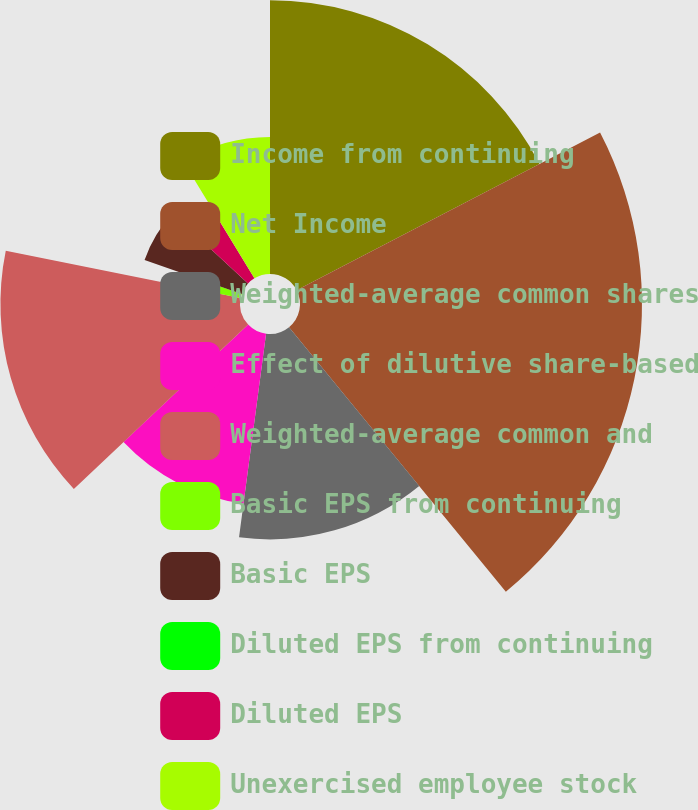Convert chart. <chart><loc_0><loc_0><loc_500><loc_500><pie_chart><fcel>Income from continuing<fcel>Net Income<fcel>Weighted-average common shares<fcel>Effect of dilutive share-based<fcel>Weighted-average common and<fcel>Basic EPS from continuing<fcel>Basic EPS<fcel>Diluted EPS from continuing<fcel>Diluted EPS<fcel>Unexercised employee stock<nl><fcel>17.37%<fcel>21.7%<fcel>13.03%<fcel>10.87%<fcel>15.2%<fcel>2.2%<fcel>6.53%<fcel>0.03%<fcel>4.37%<fcel>8.7%<nl></chart> 